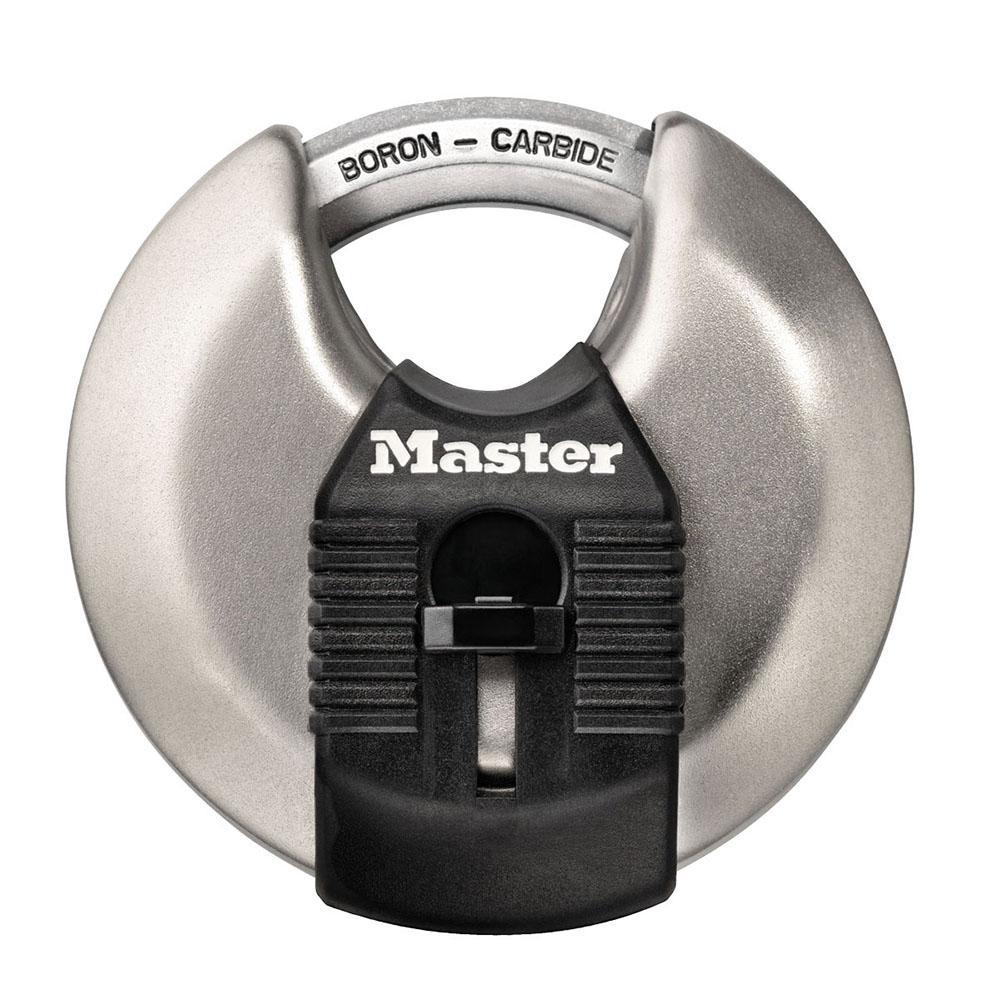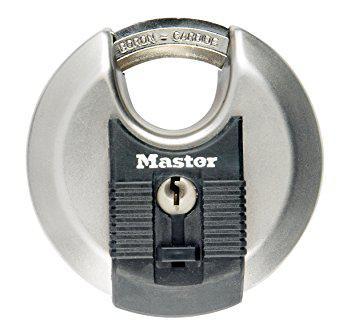The first image is the image on the left, the second image is the image on the right. Analyze the images presented: Is the assertion "Each image shows one non-square lock, and neither lock has wheels with a combination on the front." valid? Answer yes or no. Yes. The first image is the image on the left, the second image is the image on the right. Examine the images to the left and right. Is the description "All of the locks require keys." accurate? Answer yes or no. Yes. 